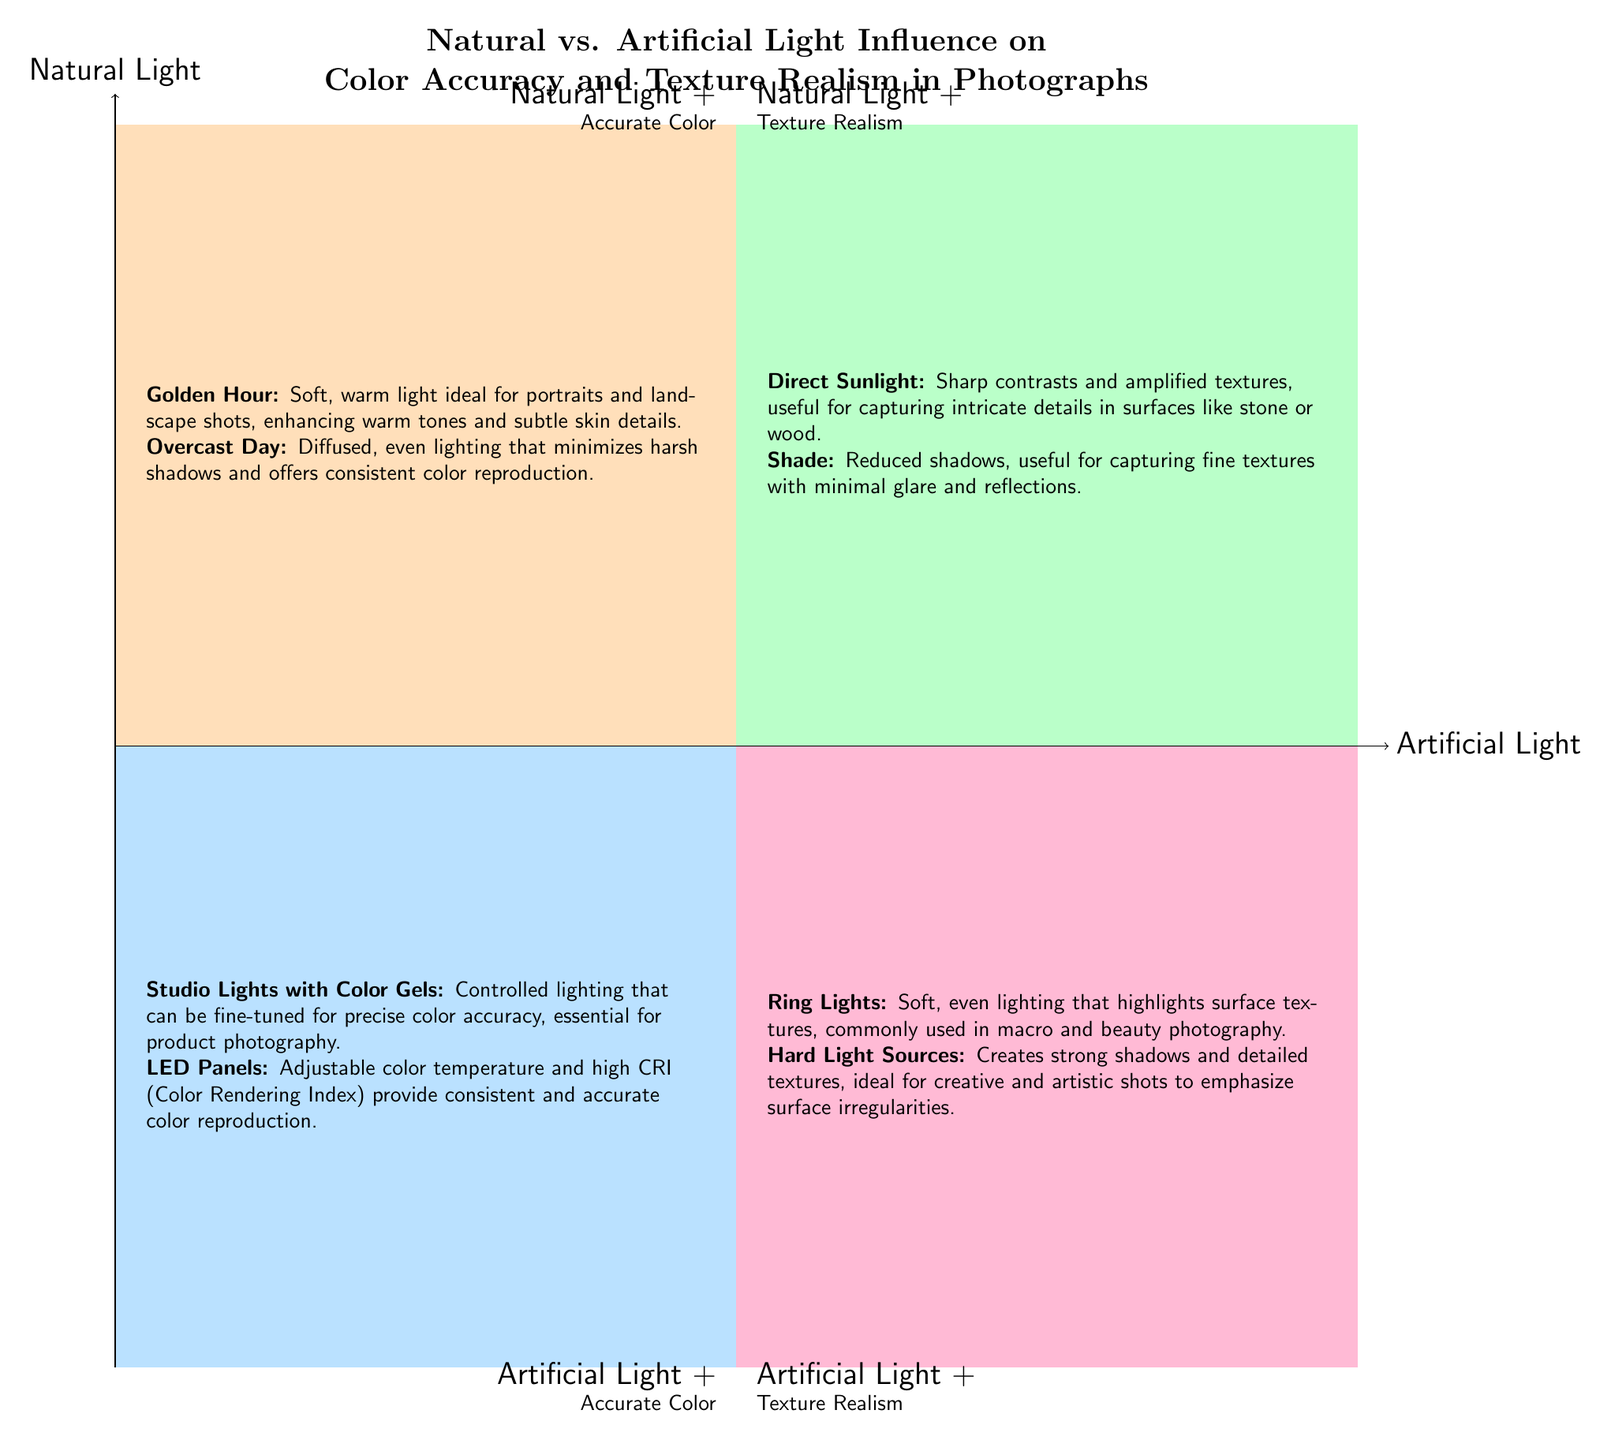What are the two categories of artificial light in the diagram? The diagram lists "Artificial Light + Accurate Color" and "Artificial Light + Texture Realism" as the two categories of artificial light.
Answer: Artificial Light + Accurate Color; Artificial Light + Texture Realism How many types of natural light are mentioned in the "Natural Light + Accurate Color" quadrant? According to the diagram, there are two types of natural light mentioned in that quadrant: "Golden Hour" and "Overcast Day."
Answer: 2 Which natural lighting scenario is described as having reduced shadows? In the "Natural Light + Texture Realism" quadrant, "Shade" is noted for its reduced shadows, making it useful for capturing fine textures.
Answer: Shade What is the primary characteristic of "Studio Lights with Color Gels"? "Studio Lights with Color Gels" are described as having controlled lighting that can be fine-tuned for precise color accuracy, which is essential for product photography.
Answer: Controlled lighting for precise color accuracy Which quadrant features "Hard Light Sources"? "Hard Light Sources" is located in the "Artificial Light + Texture Realism" quadrant, indicating it is specifically associated with producing strong shadows and detailed textures.
Answer: Artificial Light + Texture Realism What is the advantage of using "Overcast Day" lighting for photography? "Overcast Day" lighting provides diffused, even lighting, minimizing harsh shadows and offering consistent color reproduction, which is beneficial for certain types of photography.
Answer: Minimizes harsh shadows; consistent color reproduction Which type of light is ideal for capturing intricate details in surfaces like stone or wood? The "Direct Sunlight" scenario from the "Natural Light + Texture Realism" quadrant is identified as ideal for capturing intricate details in such surfaces due to its sharp contrasts and amplified textures.
Answer: Direct Sunlight What are the two key benefits of using LED Panels as mentioned in the diagram? LED Panels are described as providing adjustable color temperature and high CRI (Color Rendering Index), which gives consistent and accurate color reproduction.
Answer: Adjustable color temperature; high CRI What lighting condition is indicated as soft and warm, suitable for portraits? "Golden Hour" is highlighted in the "Natural Light + Accurate Color" quadrant as the soft, warm lighting ideal for portraits.
Answer: Golden Hour 